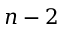<formula> <loc_0><loc_0><loc_500><loc_500>n - 2</formula> 